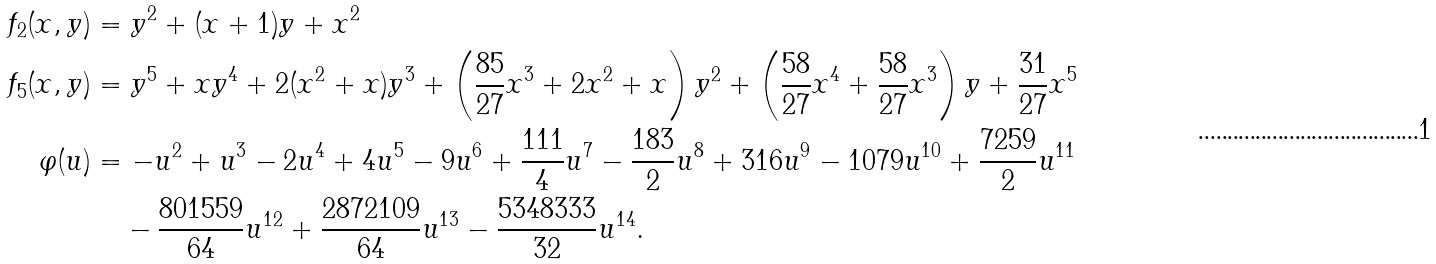Convert formula to latex. <formula><loc_0><loc_0><loc_500><loc_500>f _ { 2 } ( x , y ) & = y ^ { 2 } + ( x + 1 ) y + x ^ { 2 } \\ f _ { 5 } ( x , y ) & = y ^ { 5 } + x y ^ { 4 } + 2 ( x ^ { 2 } + x ) y ^ { 3 } + \left ( \frac { 8 5 } { 2 7 } x ^ { 3 } + 2 x ^ { 2 } + x \right ) y ^ { 2 } + \left ( \frac { 5 8 } { 2 7 } x ^ { 4 } + \frac { 5 8 } { 2 7 } x ^ { 3 } \right ) y + \frac { 3 1 } { 2 7 } x ^ { 5 } \\ \varphi ( u ) & = - u ^ { 2 } + u ^ { 3 } - 2 u ^ { 4 } + 4 u ^ { 5 } - 9 u ^ { 6 } + \frac { 1 1 1 } { 4 } u ^ { 7 } - \frac { 1 8 3 } { 2 } u ^ { 8 } + 3 1 6 u ^ { 9 } - 1 0 7 9 u ^ { 1 0 } + \frac { 7 2 5 9 } { 2 } u ^ { 1 1 } \\ & \quad - \frac { 8 0 1 5 5 9 } { 6 4 } u ^ { 1 2 } + \frac { 2 8 7 2 1 0 9 } { 6 4 } u ^ { 1 3 } - \frac { 5 3 4 8 3 3 3 } { 3 2 } u ^ { 1 4 } .</formula> 